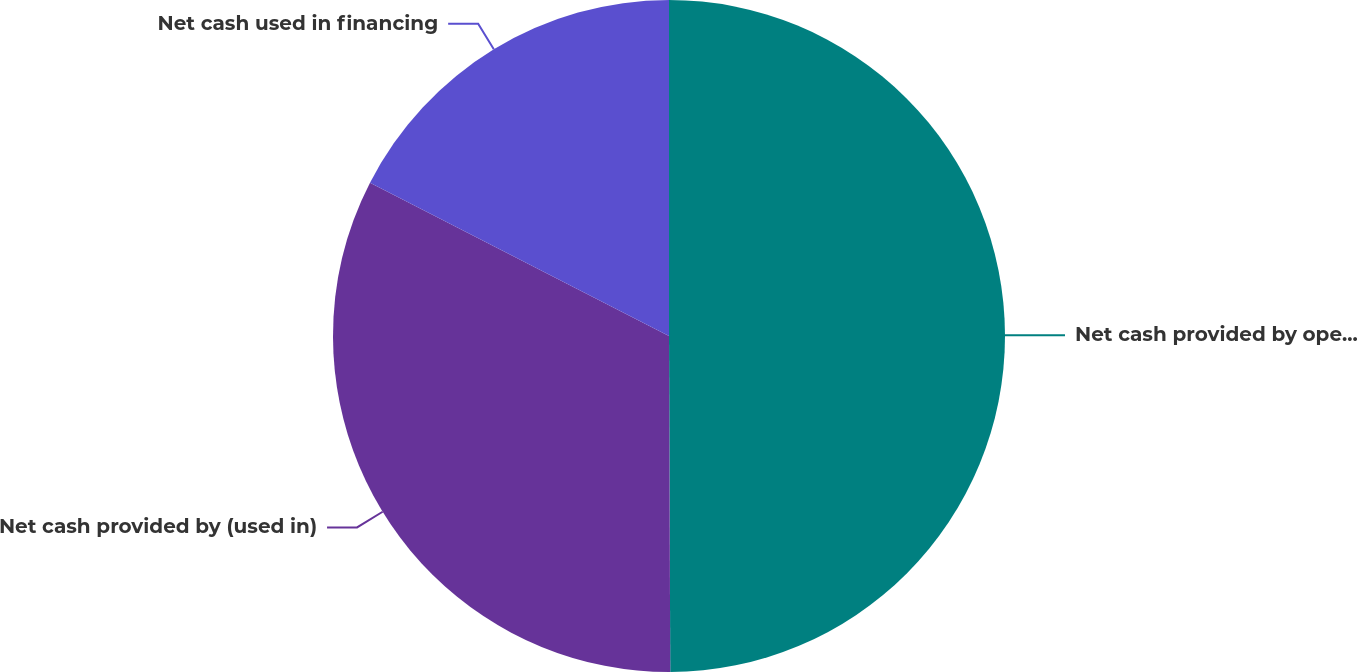<chart> <loc_0><loc_0><loc_500><loc_500><pie_chart><fcel>Net cash provided by operating<fcel>Net cash provided by (used in)<fcel>Net cash used in financing<nl><fcel>49.94%<fcel>32.6%<fcel>17.46%<nl></chart> 